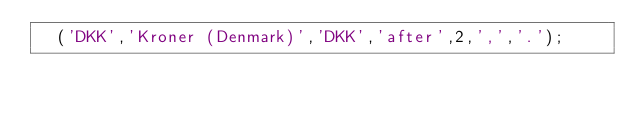<code> <loc_0><loc_0><loc_500><loc_500><_SQL_>	('DKK','Kroner (Denmark)','DKK','after',2,',','.');
</code> 